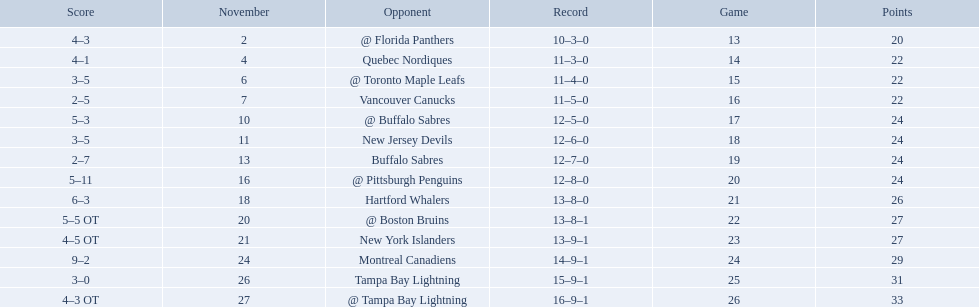Who are all of the teams? @ Florida Panthers, Quebec Nordiques, @ Toronto Maple Leafs, Vancouver Canucks, @ Buffalo Sabres, New Jersey Devils, Buffalo Sabres, @ Pittsburgh Penguins, Hartford Whalers, @ Boston Bruins, New York Islanders, Montreal Canadiens, Tampa Bay Lightning. Can you parse all the data within this table? {'header': ['Score', 'November', 'Opponent', 'Record', 'Game', 'Points'], 'rows': [['4–3', '2', '@ Florida Panthers', '10–3–0', '13', '20'], ['4–1', '4', 'Quebec Nordiques', '11–3–0', '14', '22'], ['3–5', '6', '@ Toronto Maple Leafs', '11–4–0', '15', '22'], ['2–5', '7', 'Vancouver Canucks', '11–5–0', '16', '22'], ['5–3', '10', '@ Buffalo Sabres', '12–5–0', '17', '24'], ['3–5', '11', 'New Jersey Devils', '12–6–0', '18', '24'], ['2–7', '13', 'Buffalo Sabres', '12–7–0', '19', '24'], ['5–11', '16', '@ Pittsburgh Penguins', '12–8–0', '20', '24'], ['6–3', '18', 'Hartford Whalers', '13–8–0', '21', '26'], ['5–5 OT', '20', '@ Boston Bruins', '13–8–1', '22', '27'], ['4–5 OT', '21', 'New York Islanders', '13–9–1', '23', '27'], ['9–2', '24', 'Montreal Canadiens', '14–9–1', '24', '29'], ['3–0', '26', 'Tampa Bay Lightning', '15–9–1', '25', '31'], ['4–3 OT', '27', '@ Tampa Bay Lightning', '16–9–1', '26', '33']]} What games finished in overtime? 22, 23, 26. In game number 23, who did they face? New York Islanders. 